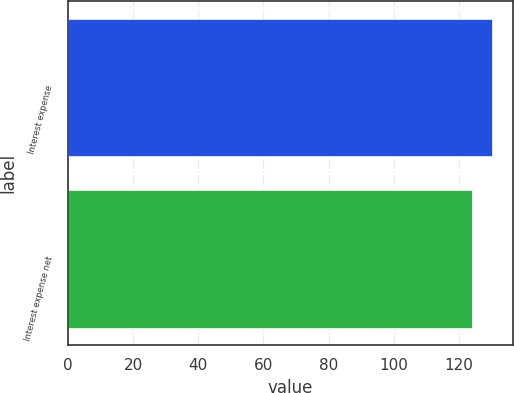Convert chart. <chart><loc_0><loc_0><loc_500><loc_500><bar_chart><fcel>Interest expense<fcel>Interest expense net<nl><fcel>130<fcel>124<nl></chart> 